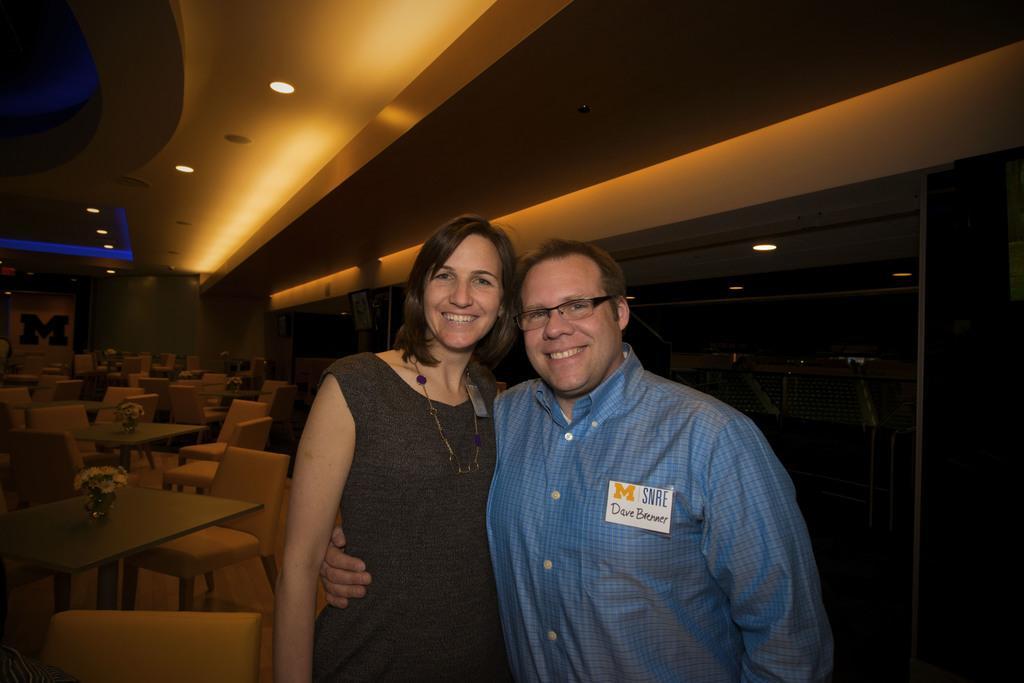How would you summarize this image in a sentence or two? This picture is clicked in a room. There are two persons, one woman and one man. Women is wearing a grey dress and man is wearing a blue check shirt. The room was filled with the empty chairs and tables, for each table there is a flower vase. In the top left there is a ceiling and lights. In the right side there is a glass door. 